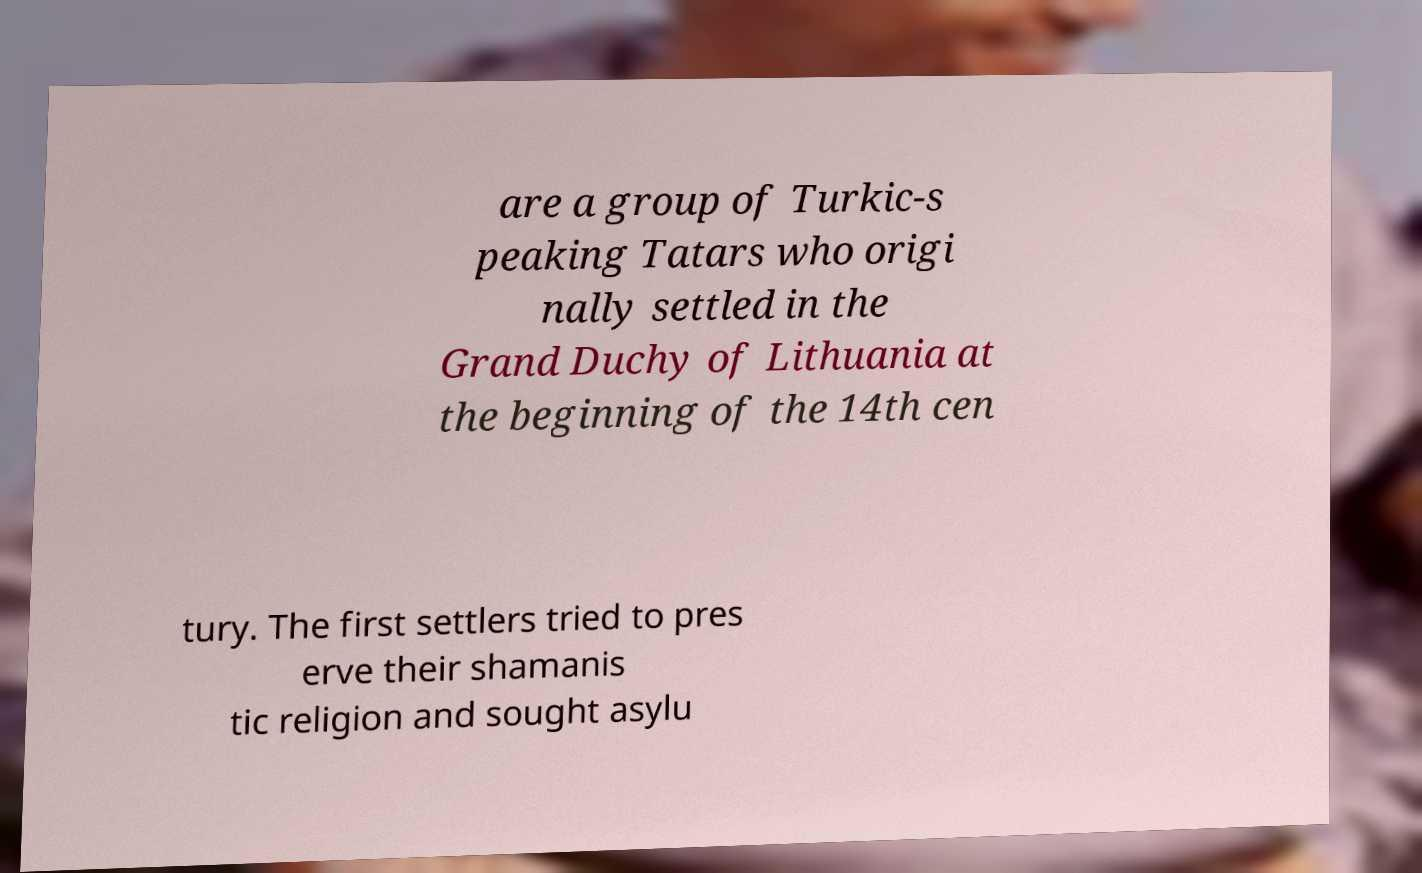Can you read and provide the text displayed in the image?This photo seems to have some interesting text. Can you extract and type it out for me? are a group of Turkic-s peaking Tatars who origi nally settled in the Grand Duchy of Lithuania at the beginning of the 14th cen tury. The first settlers tried to pres erve their shamanis tic religion and sought asylu 